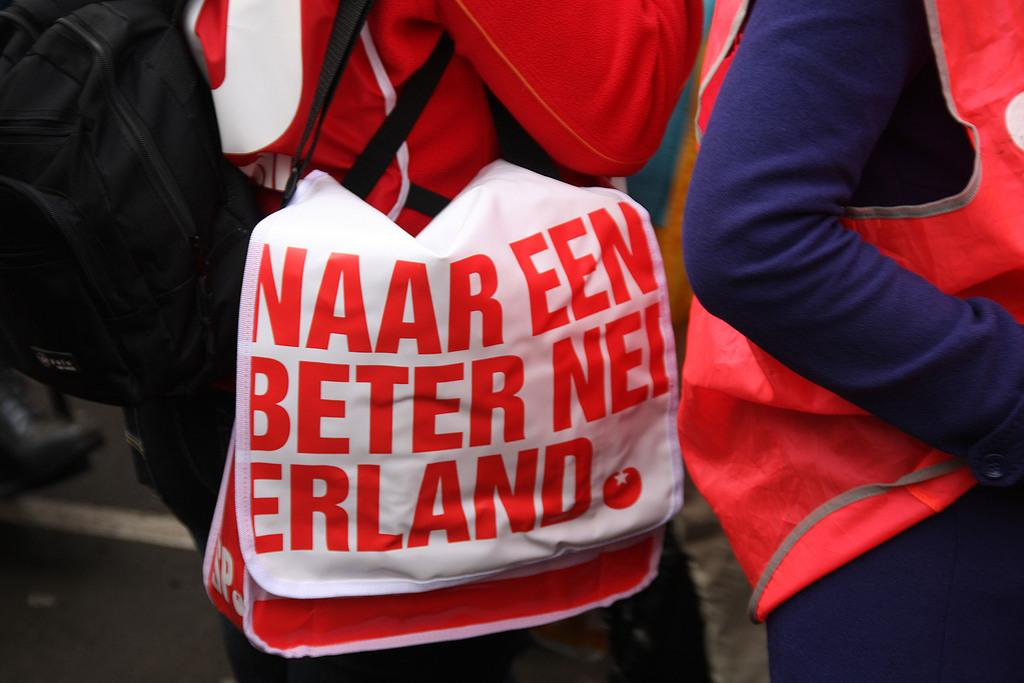<image>
Relay a brief, clear account of the picture shown. A woman with a bag that says Naar Een Beter Nei Erland. 